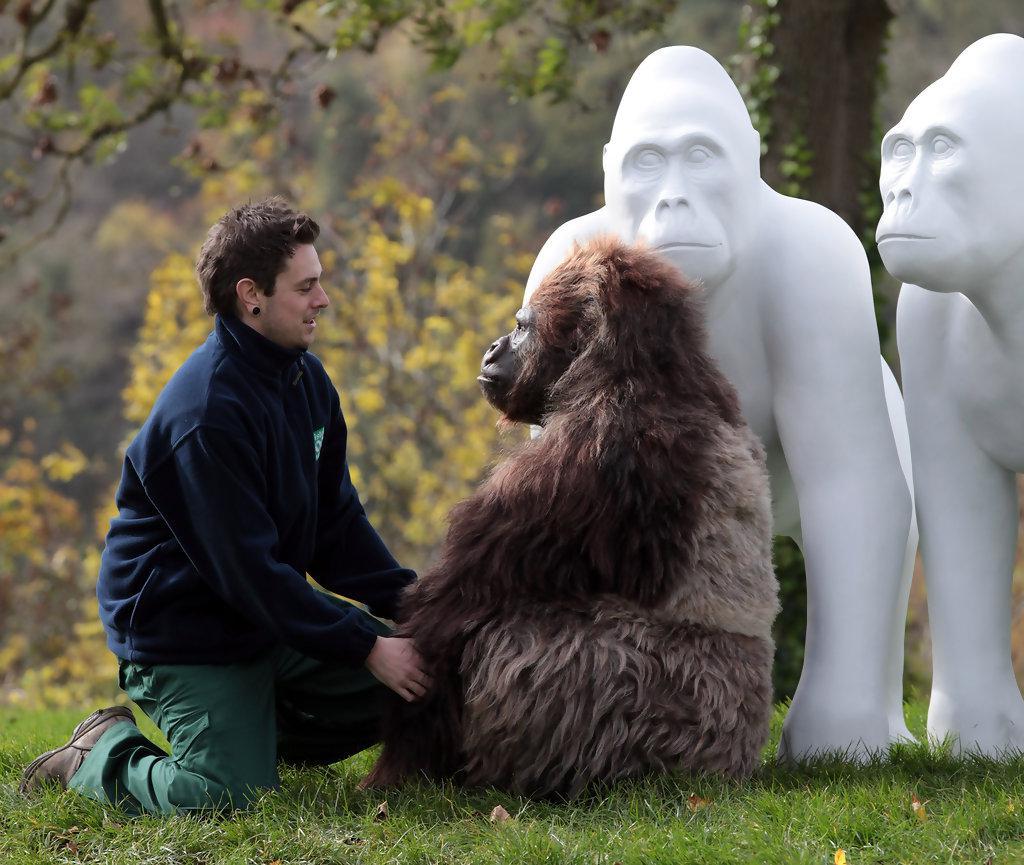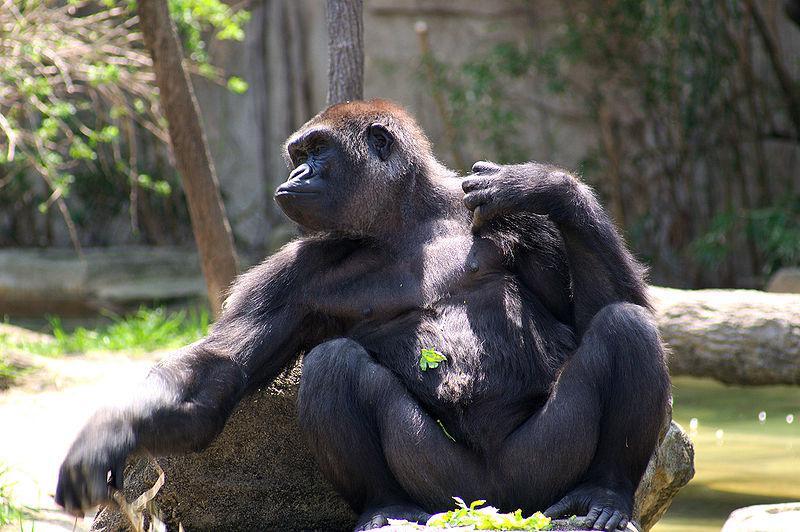The first image is the image on the left, the second image is the image on the right. Analyze the images presented: Is the assertion "At least one person is present with an ape in one of the images." valid? Answer yes or no. Yes. 